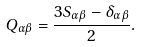<formula> <loc_0><loc_0><loc_500><loc_500>Q _ { \alpha \beta } = \frac { 3 S _ { \alpha \beta } - \delta _ { \alpha \beta } } { 2 } .</formula> 